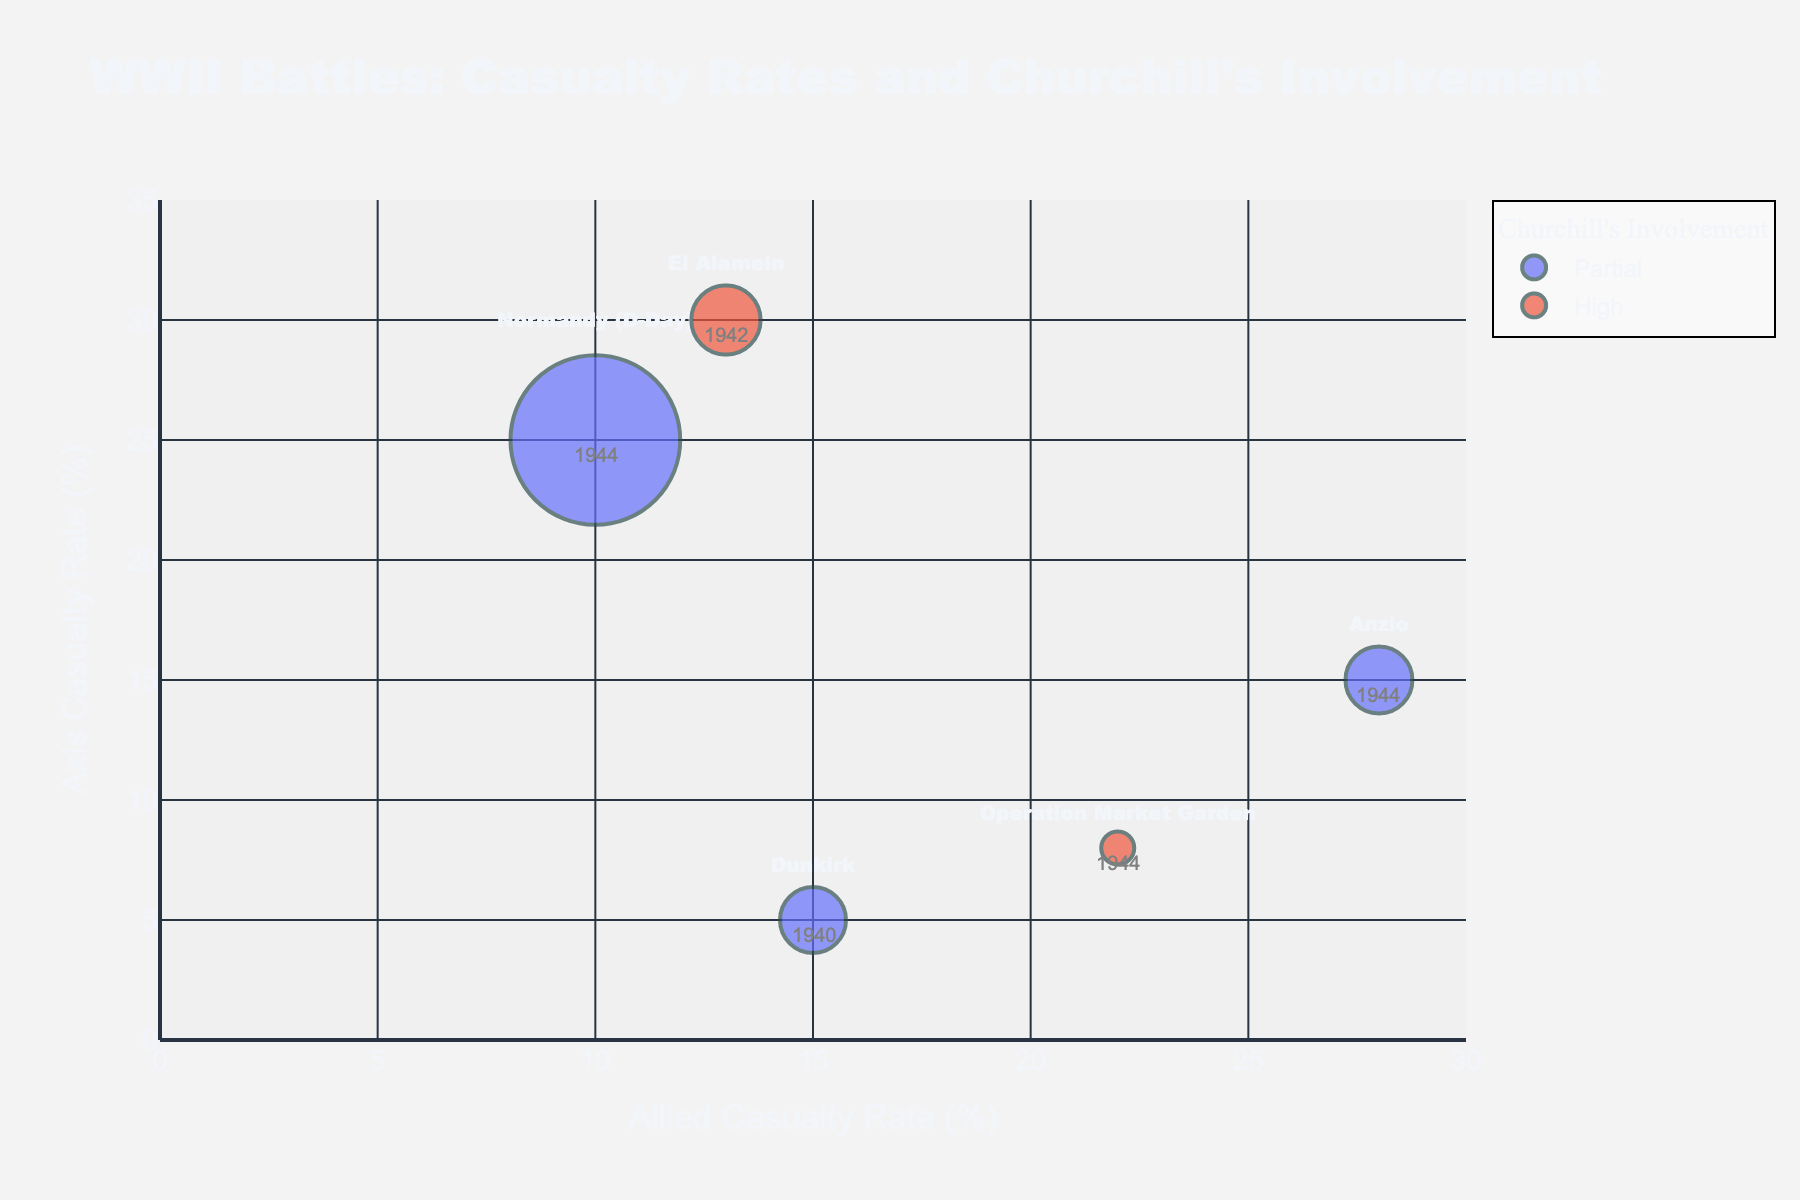How many battles are shown in the figure? To determine the number of battles, count the bubbles representing each battle in the plot.
Answer: 5 Which battle has the highest Allied casualty rate? Look at the x-axis, which represents the Allied casualty rate, and identify the battle with the highest x-coordinate.
Answer: Anzio Which battle has the largest total casualties? The size of the bubbles represents the total casualties; the largest bubble corresponds to the battle with the largest casualties.
Answer: Normandy (D-Day) What is Churchill's involvement in the battle with the fewest total casualties? Identify the smallest bubble, which corresponds to the battle with the fewest casualties, and check its color to determine Churchill's involvement.
Answer: High (Operation Market Garden) Compare the Allied and Axis casualty rates for the battle of El Alamein. For the battle of El Alamein, note the x-coordinate for the Allied casualty rate (13%) and the y-coordinate for the Axis casualty rate (30%).
Answer: Allied: 13%, Axis: 30% What is the average Allied casualty rate among the battles with partial decision involvement by Churchill? Identify the battles with partial decision involvement (Dunkirk, Normandy, and Anzio), sum their Allied casualty rates (15% + 10% + 28%), and divide by the number of battles (3).
Answer: 17.67% Which battle's bubble is the closest to the origin (0,0) on the plot? Analyze each bubble's coordinates and find the one with the smallest values for both Allied and Axis casualty rates.
Answer: Dunkirk Compare the total casualties in El Alamein and Operation Market Garden. Identify the sizes of the bubbles representing El Alamein (75000) and Operation Market Garden (17000), and find the difference or ratio.
Answer: El Alamein: 75000, Operation Market Garden: 17000 Rank the battles based on their Axis casualty rates from highest to lowest. Arrange the battles according to their y-coordinates (Axis casualty rates) in descending order.
Answer: El Alamein, Normandy, Anzio, Dunkirk, Operation Market Garden 